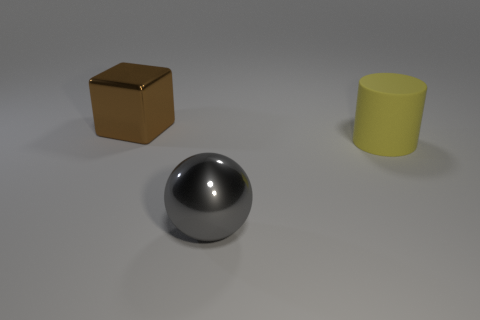Is there a thing made of the same material as the big cube?
Keep it short and to the point. Yes. What number of rubber objects are tiny brown cylinders or large yellow cylinders?
Ensure brevity in your answer.  1. There is a thing that is on the left side of the large metallic thing that is in front of the brown cube; what shape is it?
Provide a succinct answer. Cube. Is the number of large things that are behind the brown cube less than the number of tiny yellow cubes?
Give a very brief answer. No. What is the shape of the big brown thing?
Make the answer very short. Cube. What color is the rubber thing that is the same size as the block?
Provide a short and direct response. Yellow. Is the number of cylinders that are to the left of the big brown metallic thing less than the number of gray things that are in front of the large yellow object?
Your answer should be compact. Yes. What is the material of the object that is both behind the gray object and to the left of the yellow cylinder?
Ensure brevity in your answer.  Metal. What number of other objects are there of the same size as the gray ball?
Offer a terse response. 2. Is the number of shiny blocks greater than the number of big cyan metal spheres?
Give a very brief answer. Yes. 